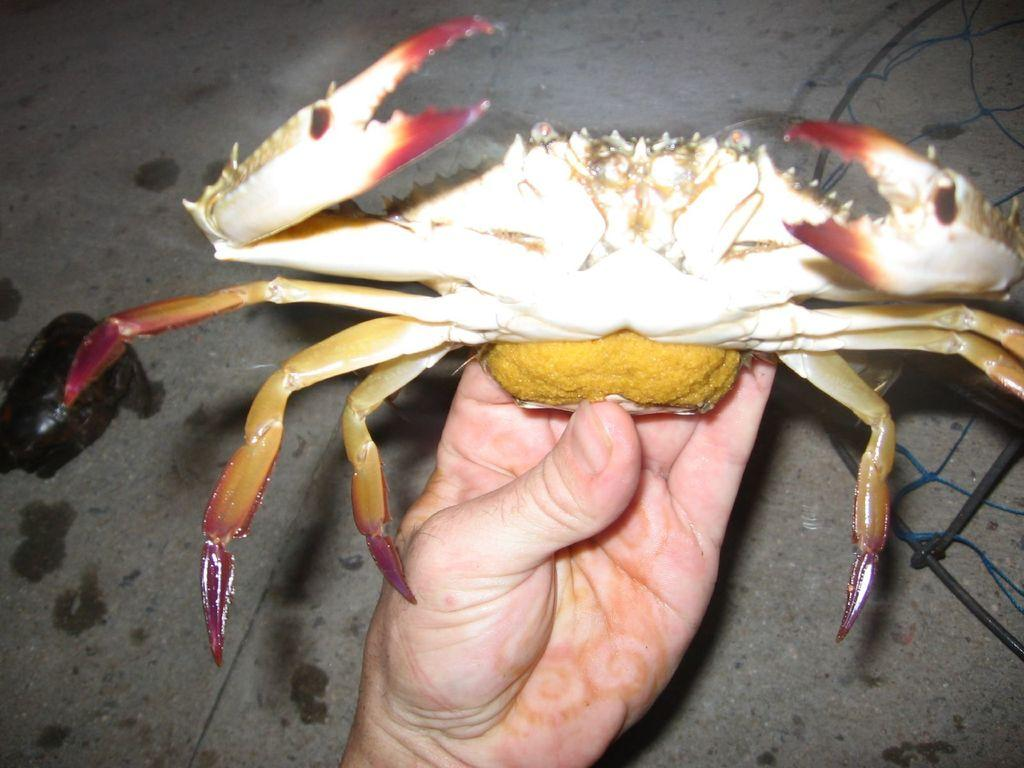What is the person's hand holding in the image? There is a person's hand holding a crab in the image. What can be seen on the right side of the image? There is a net on the right side of the image. What type of paste is being used to attach the thread to the chair in the image? There is no paste, thread, or chair present in the image. 